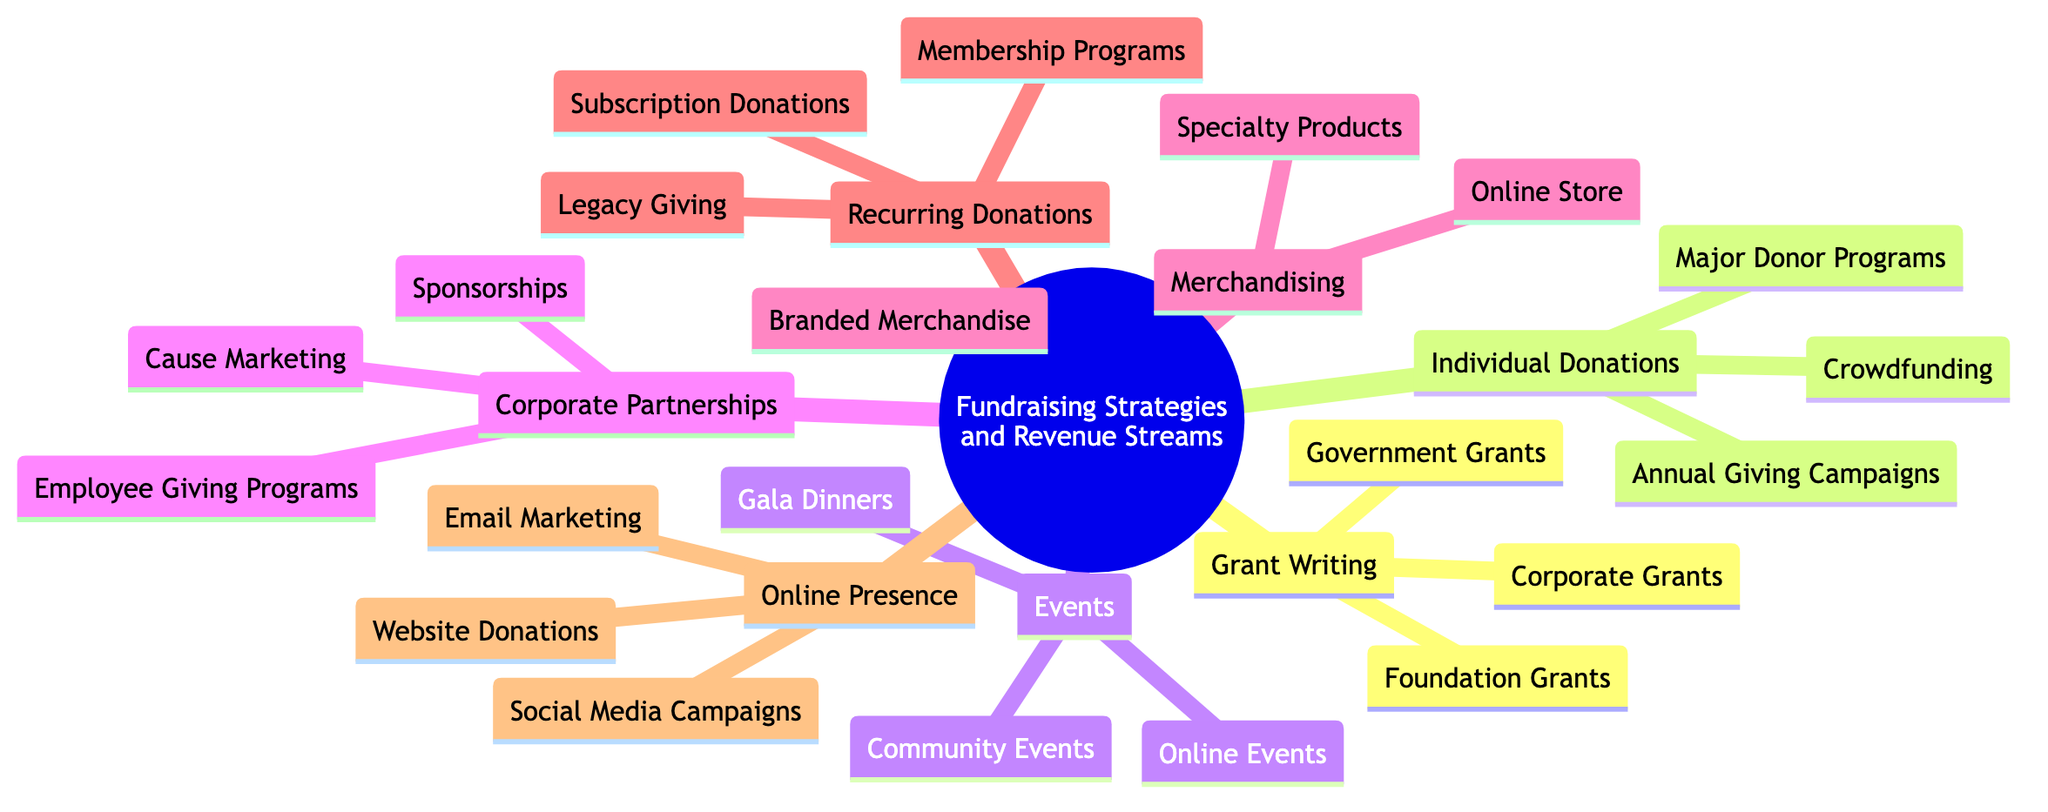What are the three main categories of fundraising strategies? The main categories can be identified as the three primary branches of the mind map: Grant Writing, Individual Donations, and Events. Each of these branches represents a distinct category of fundraising approach.
Answer: Grant Writing, Individual Donations, Events How many types of individual donations are listed in the diagram? To find this, we look under the Individual Donations branch, which contains three specific types: Major Donor Programs, Annual Giving Campaigns, and Crowdfunding. Counting these gives us the total.
Answer: 3 What type of fundraising strategy involves virtual events? By examining the Events branch, we can see that Online Events is one of the types listed. This indicates that it falls under the category of Events for fundraising strategies.
Answer: Online Events Which type of fundraising strategy focuses on recurring support? We look at the Recurring Donations branch, which signifies the strategy focused on obtaining consistent support over time; the branch itself identifies this strategy.
Answer: Recurring Donations How many strategies are mentioned under Corporate Partnerships? This can be determined by counting the items listed under the Corporate Partnerships branch: Sponsorships, Cause Marketing, and Employee Giving Programs. This gives us a total of three.
Answer: 3 Which fundraising strategy utilizes eCommerce features? The Merchandising branch includes the Online Store type, which directly indicates the use of eCommerce to facilitate sales and donations.
Answer: Online Store What is the relationship between Corporate Partnerships and Employee Giving Programs? Employee Giving Programs is a sub-category within the Corporate Partnerships branch, meaning it is a specific strategy under the broader category of Corporate Partnerships.
Answer: Sub-category What is a method listed for enhancing online donations? The Online Presence branch lists Website Donations as a direct method to optimize online donations, showcasing its importance in this strategy.
Answer: Website Donations What type of event comprises large gatherings for fundraising? Within the Events category of the mind map, Gala Dinners are specifically mentioned as large fundraising events that provide entertainment and auctions.
Answer: Gala Dinners 